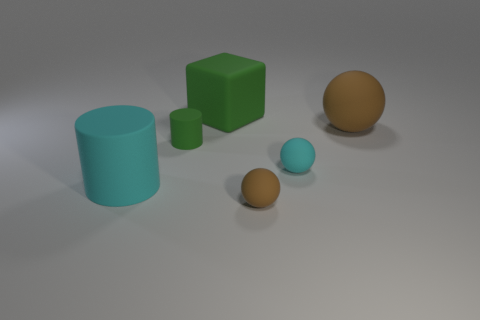Add 3 tiny brown matte things. How many objects exist? 9 Subtract all gray cylinders. Subtract all gray cubes. How many cylinders are left? 2 Subtract all cylinders. How many objects are left? 4 Add 2 large blue cubes. How many large blue cubes exist? 2 Subtract 0 gray spheres. How many objects are left? 6 Subtract all small blue things. Subtract all tiny green things. How many objects are left? 5 Add 5 rubber cubes. How many rubber cubes are left? 6 